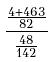<formula> <loc_0><loc_0><loc_500><loc_500>\frac { \frac { 4 + 4 6 3 } { 8 2 } } { \frac { 4 8 } { 1 4 2 } }</formula> 